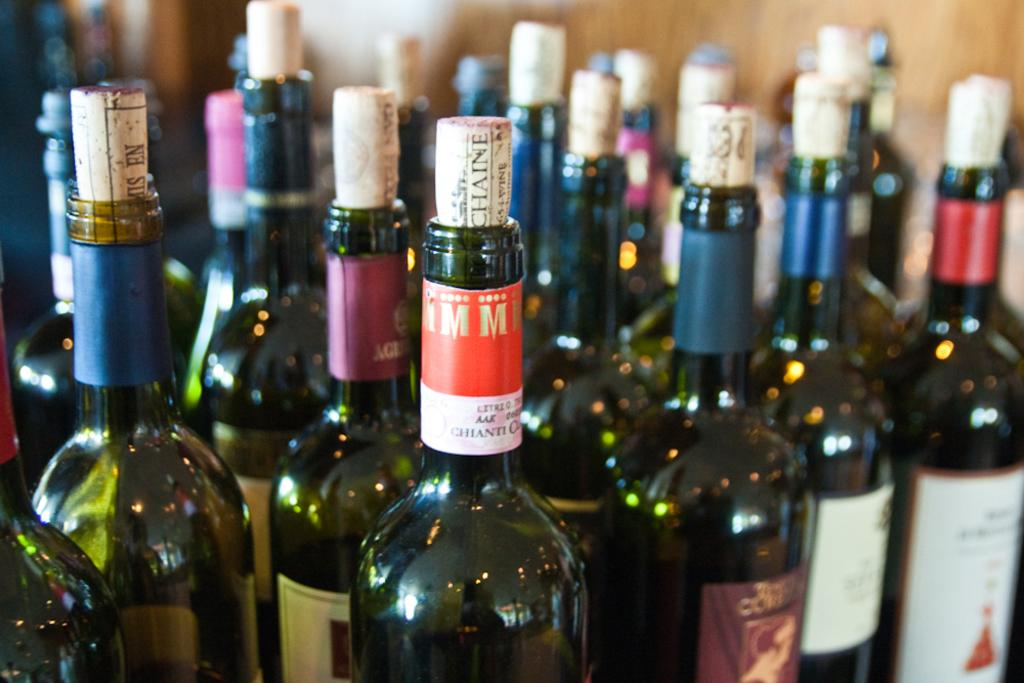<image>
Write a terse but informative summary of the picture. Several corked bottles of alcohol including a Chainti. 